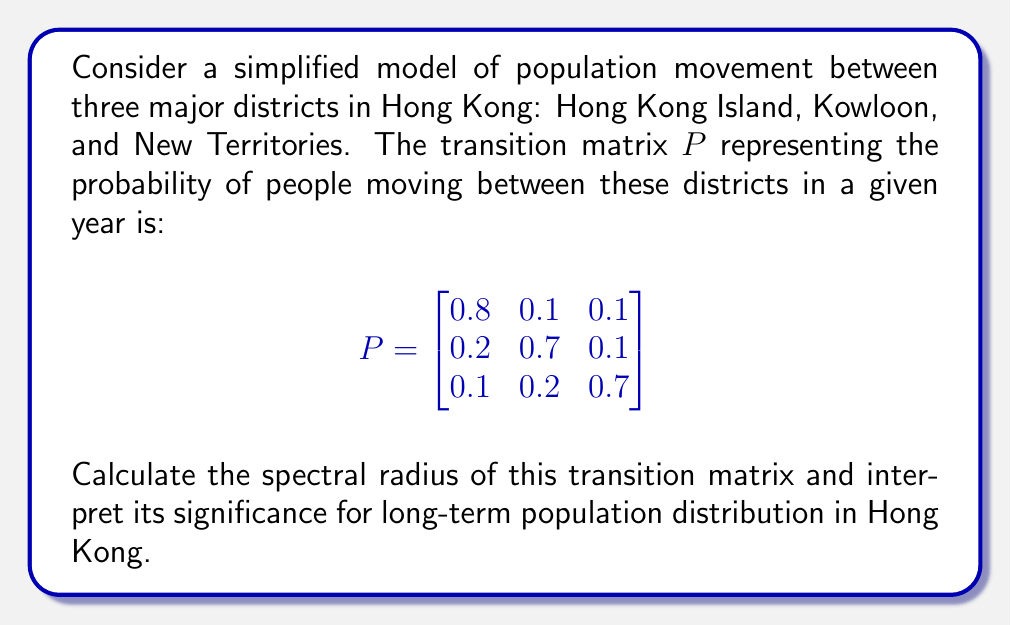Can you answer this question? To find the spectral radius of the transition matrix $P$, we need to follow these steps:

1) First, recall that the spectral radius is the largest absolute value of the eigenvalues of the matrix.

2) To find the eigenvalues, we need to solve the characteristic equation:
   $$\det(P - \lambda I) = 0$$

3) Expanding this determinant:
   $$\begin{vmatrix}
   0.8-\lambda & 0.1 & 0.1 \\
   0.2 & 0.7-\lambda & 0.1 \\
   0.1 & 0.2 & 0.7-\lambda
   \end{vmatrix} = 0$$

4) This yields the characteristic polynomial:
   $$-\lambda^3 + 2.2\lambda^2 - 1.51\lambda + 0.31 = 0$$

5) Solving this equation (using numerical methods as it's a cubic equation) gives us the eigenvalues:
   $\lambda_1 = 1$, $\lambda_2 \approx 0.6$, $\lambda_3 \approx 0.6$

6) The spectral radius is the largest absolute value among these eigenvalues, which is 1.

7) Interpretation: The spectral radius of 1 indicates that the Markov chain is ergodic and has a unique stationary distribution. This means that in the long run, the population distribution among the three districts will converge to a stable state, regardless of the initial distribution.

8) The eigenvalue 1 corresponds to this stationary distribution. The other eigenvalues being less than 1 in magnitude indicate that any initial deviations from the stationary distribution will decay over time.

9) This stability is crucial for long-term urban planning and resource allocation in Hong Kong, ensuring a predictable population distribution across the three major districts.
Answer: The spectral radius is 1, indicating long-term stability in population distribution across Hong Kong's districts. 